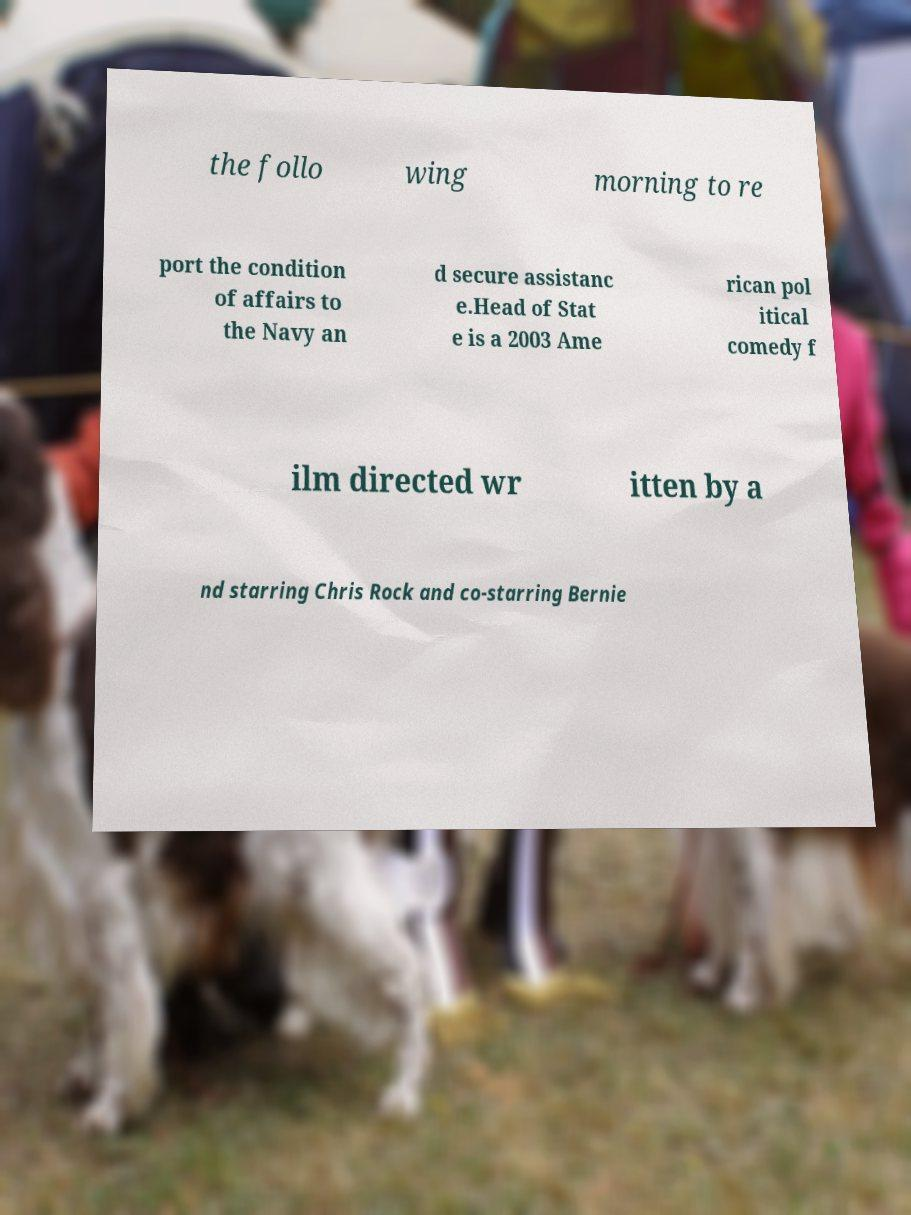For documentation purposes, I need the text within this image transcribed. Could you provide that? the follo wing morning to re port the condition of affairs to the Navy an d secure assistanc e.Head of Stat e is a 2003 Ame rican pol itical comedy f ilm directed wr itten by a nd starring Chris Rock and co-starring Bernie 